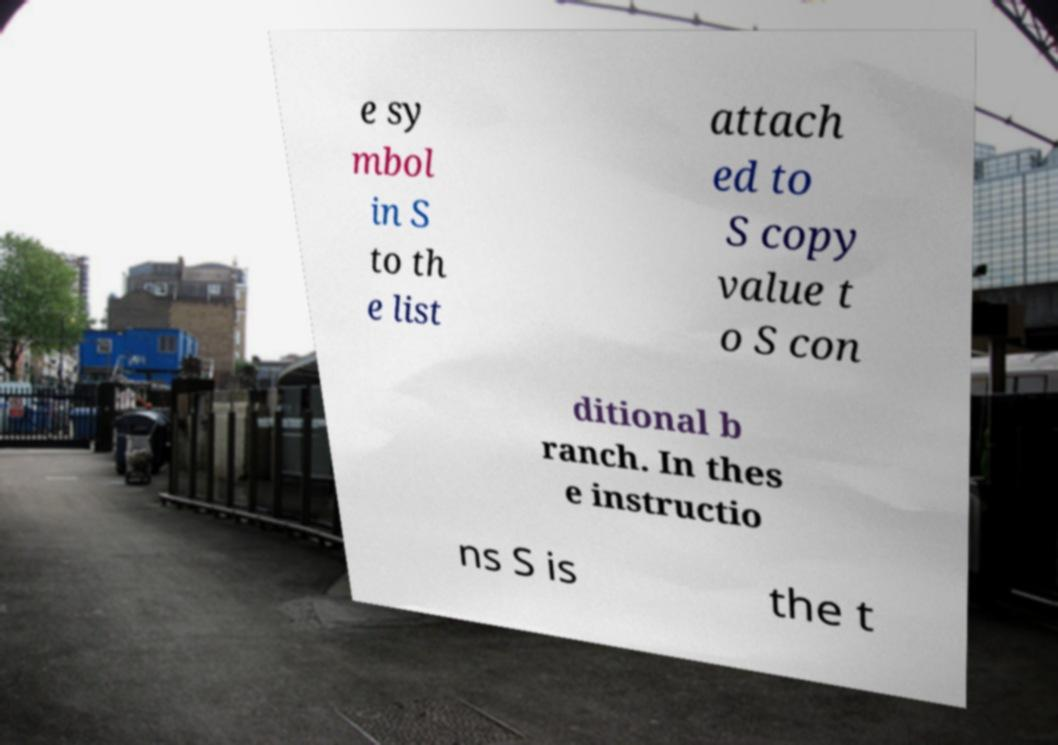What messages or text are displayed in this image? I need them in a readable, typed format. e sy mbol in S to th e list attach ed to S copy value t o S con ditional b ranch. In thes e instructio ns S is the t 